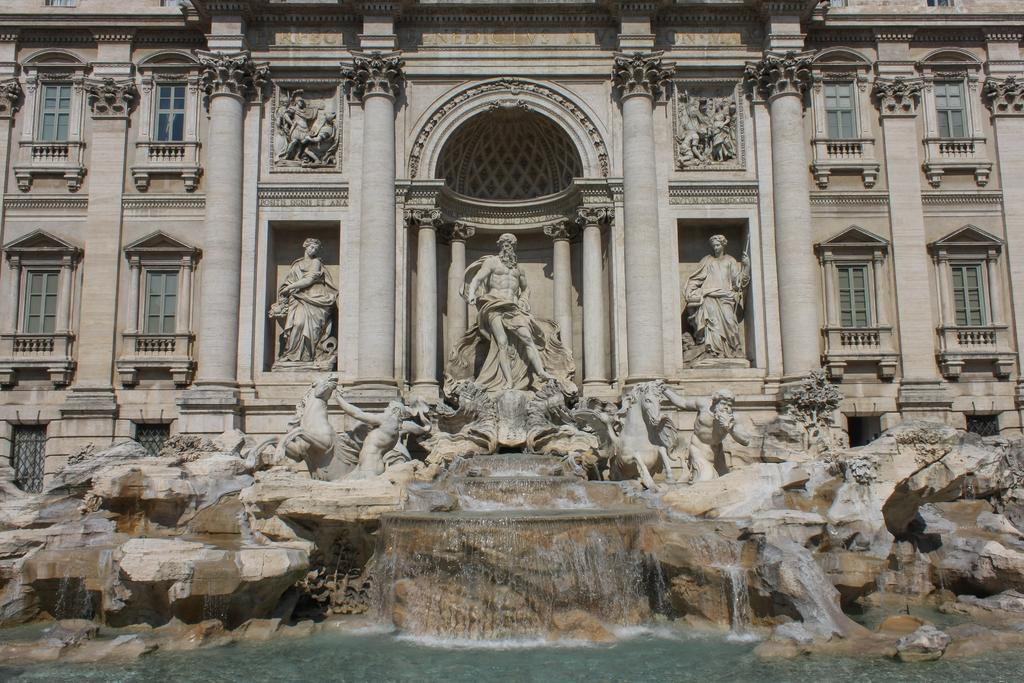What can be seen in front of the building in the image? There are sculptures in front of the building. What natural feature is present in the image? There is a waterfall in the center of the image. What type of face can be seen on the sculptures in the image? There is no face present on the sculptures in the image. How many alleys are visible in the image? There are no alleys visible in the image. 